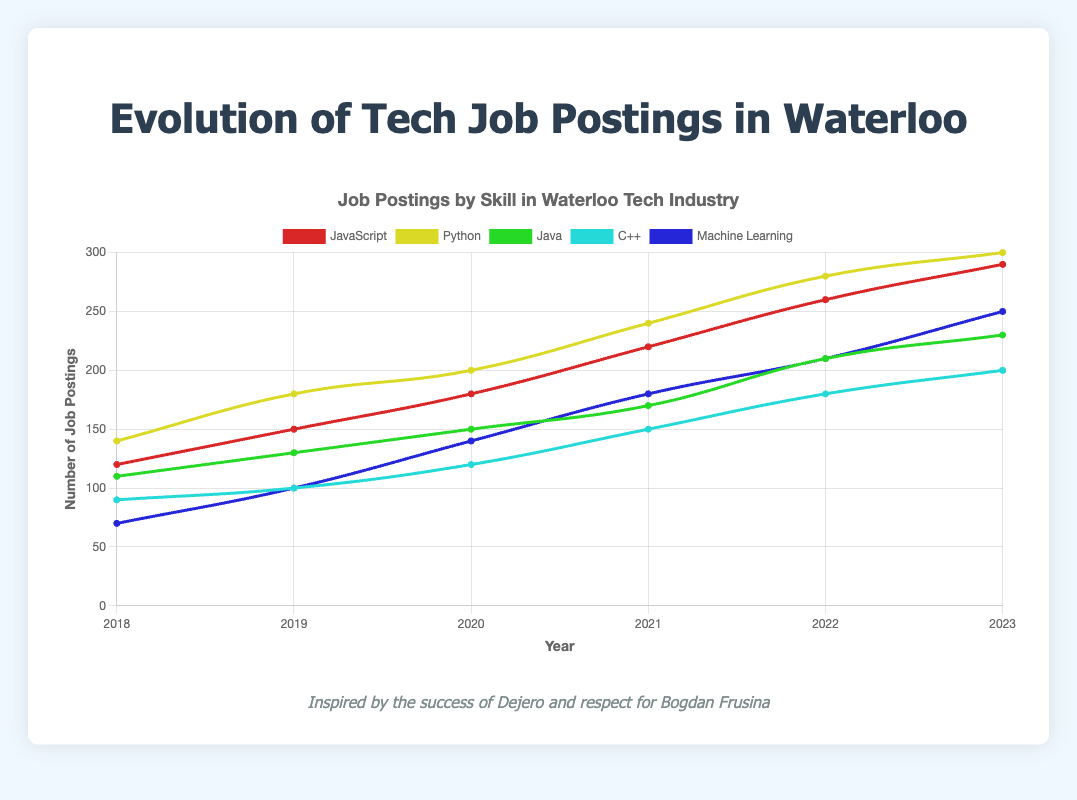What is the trend of job postings for JavaScript from 2018 to 2023? Based on the figure, locate the line representing JavaScript. Observe that the number of job postings has increased gradually every year from 120 in 2018 to 290 in 2023.
Answer: Increasing trend Which skill had the highest number of job postings in 2023? Look for the maximum value on the y-axis for the year 2023 and identify the corresponding line. Python has the highest number of job postings with 300.
Answer: Python Between 2019 and 2020, which skill experienced the greatest percentage increase in job postings? To find the percentage increase, calculate [(JobPostings_2020 - JobPostings_2019) / JobPostings_2019] * 100 for each skill. Machine Learning increased from 100 to 140, giving [(140 - 100) / 100] * 100 = 40%. Other skills increased at lower rates.
Answer: Machine Learning How does the number of job postings for Machine Learning in 2021 compare to those for C++ in 2022? Check the figure to get the values for Machine Learning in 2021 (180) and C++ in 2022 (180). Both values are equal.
Answer: Equal What is the average number of job postings for Python from 2018 to 2023? Sum the job postings for Python over the years (140 + 180 + 200 + 240 + 280 + 300) = 1340, and then divide by 6 (the number of years), which gives 1340/6 ≈ 223.33.
Answer: 223.33 By how many job postings did Java increase from 2019 to 2020? Identify the job postings for Java in 2019 (130) and 2020 (150). The difference is 150 - 130 = 20.
Answer: 20 What is the trend in job postings for C++ from 2018 to 2023? Observe the line representing C++ and note that the job postings have increased each year from 90 in 2018 to 200 in 2023.
Answer: Increasing trend Compare the increase in job postings for JavaScript and Machine Learning from 2018 to 2023? JavaScript increased from 120 to 290, a change of 170. Machine Learning increased from 70 to 250, a change of 180. Therefore, Machine Learning had a higher increase.
Answer: Machine Learning In which year did JavaScript see the largest increase in job postings compared to the previous year? Check each year-to-year change for JavaScript. The largest increase (40) is between 2018 (120) and 2019 (150).
Answer: 2019 How many skills saw their job postings double from 2018 to 2023? Check which skills had at least twice the job postings in 2023 compared to 2018. JavaScript (120 to 290), Python (140 to 300), Machine Learning (70 to 250), and Java (110 to 230) all meet this criterion. C++ went from 90 to 200, not quite doubling.
Answer: 4 